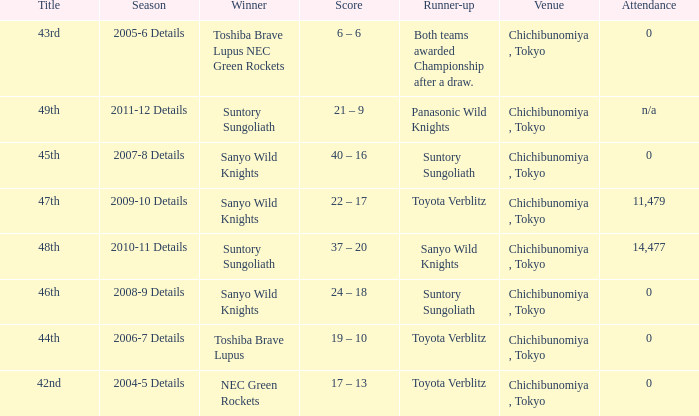What is the Attendance number for the title of 44th? 0.0. 